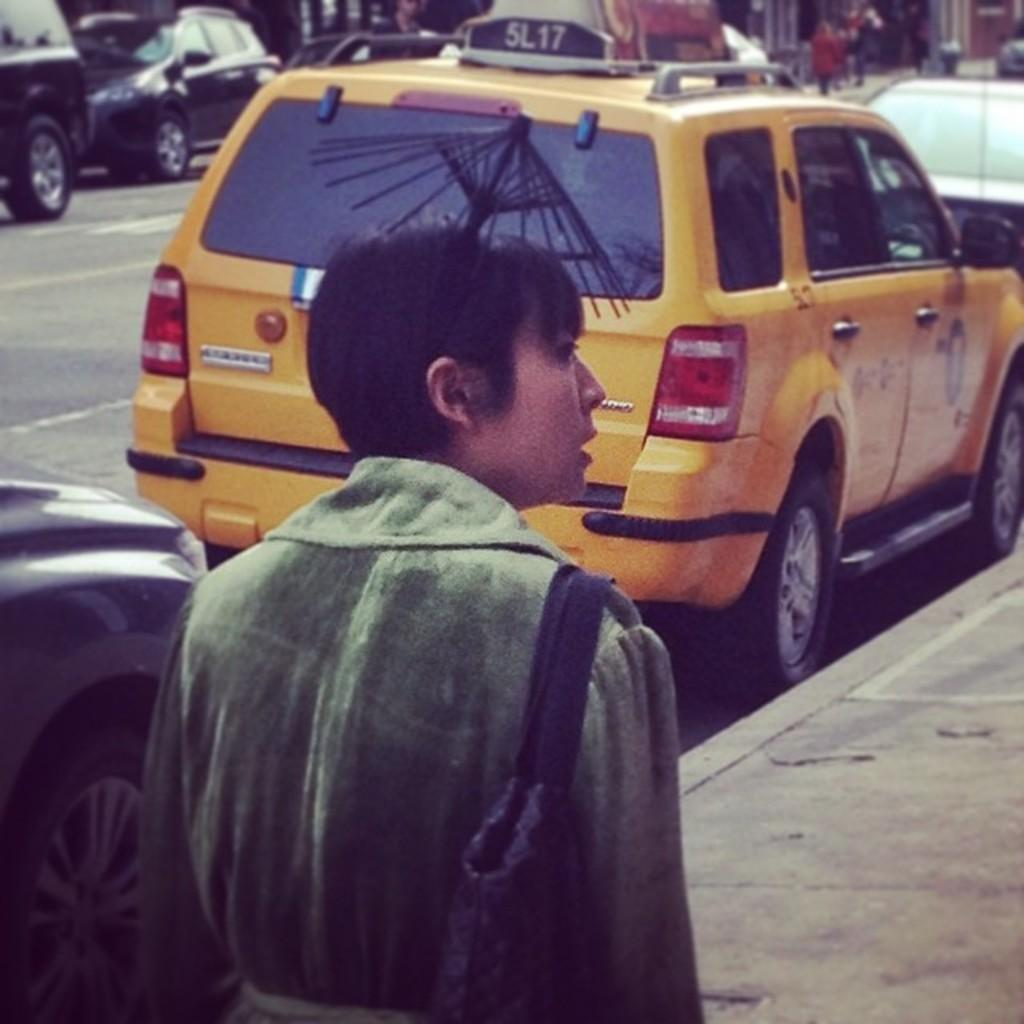<image>
Summarize the visual content of the image. A woman is walking down the sidewalk behind cab number 5L17 